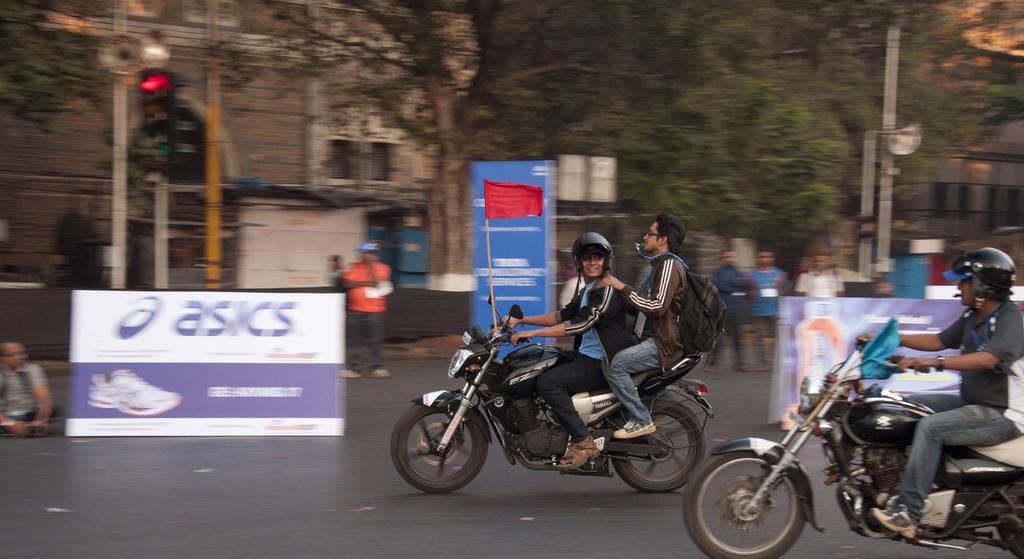Can you describe this image briefly? In this picture we can see the road some people are riding a vehicles to the vehicles some black carbon placed on is red in color and another one is blue in color back side we can see the board and signal light and one building and some of the trees in few people are walking on the road. 